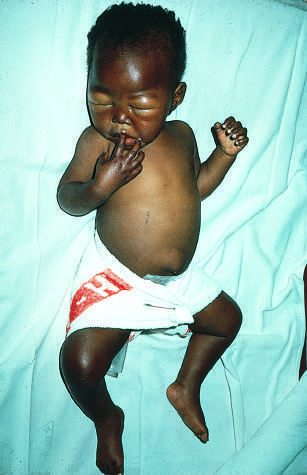does the infant show generalized edema, seen as ascites and puffiness of the face, hands, and legs?
Answer the question using a single word or phrase. Yes 